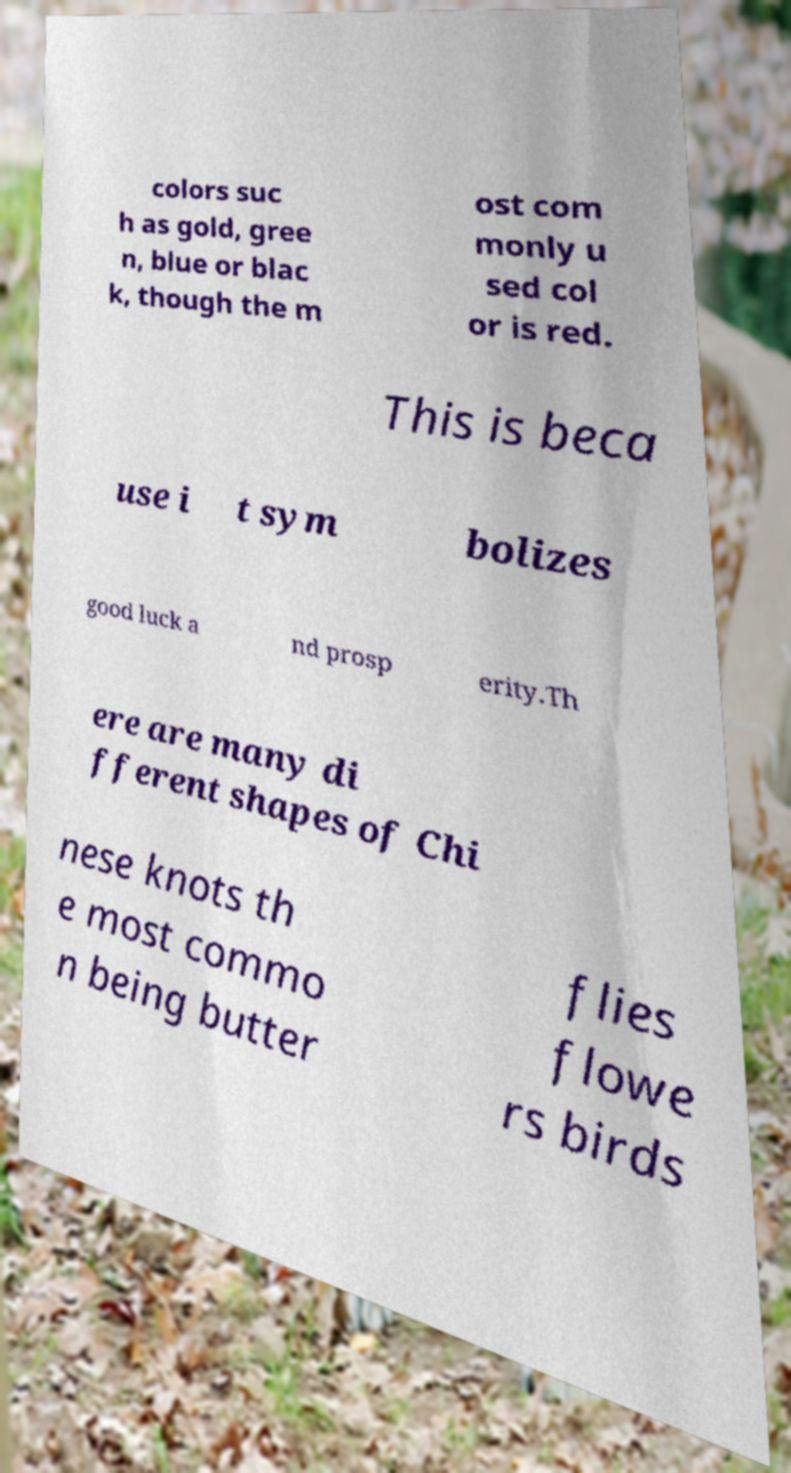For documentation purposes, I need the text within this image transcribed. Could you provide that? colors suc h as gold, gree n, blue or blac k, though the m ost com monly u sed col or is red. This is beca use i t sym bolizes good luck a nd prosp erity.Th ere are many di fferent shapes of Chi nese knots th e most commo n being butter flies flowe rs birds 